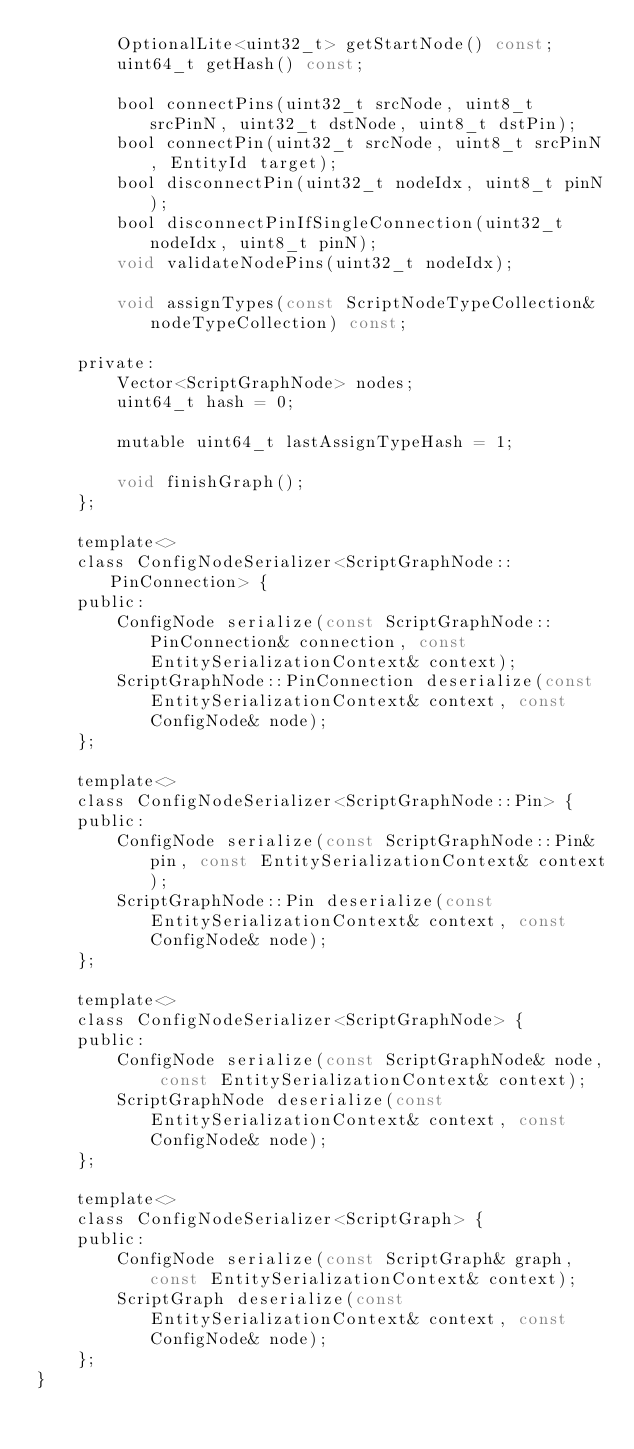Convert code to text. <code><loc_0><loc_0><loc_500><loc_500><_C_>		OptionalLite<uint32_t> getStartNode() const;
		uint64_t getHash() const;

		bool connectPins(uint32_t srcNode, uint8_t srcPinN, uint32_t dstNode, uint8_t dstPin);
		bool connectPin(uint32_t srcNode, uint8_t srcPinN, EntityId target);
		bool disconnectPin(uint32_t nodeIdx, uint8_t pinN);
		bool disconnectPinIfSingleConnection(uint32_t nodeIdx, uint8_t pinN);
		void validateNodePins(uint32_t nodeIdx);

		void assignTypes(const ScriptNodeTypeCollection& nodeTypeCollection) const;

	private:
		Vector<ScriptGraphNode> nodes;
		uint64_t hash = 0;

		mutable uint64_t lastAssignTypeHash = 1;

		void finishGraph();
	};

	template<>
	class ConfigNodeSerializer<ScriptGraphNode::PinConnection> {
	public:
		ConfigNode serialize(const ScriptGraphNode::PinConnection& connection, const EntitySerializationContext& context);
		ScriptGraphNode::PinConnection deserialize(const EntitySerializationContext& context, const ConfigNode& node);
	};

	template<>
	class ConfigNodeSerializer<ScriptGraphNode::Pin> {
	public:
		ConfigNode serialize(const ScriptGraphNode::Pin& pin, const EntitySerializationContext& context);
		ScriptGraphNode::Pin deserialize(const EntitySerializationContext& context, const ConfigNode& node);
	};

	template<>
	class ConfigNodeSerializer<ScriptGraphNode> {
	public:
		ConfigNode serialize(const ScriptGraphNode& node, const EntitySerializationContext& context);
		ScriptGraphNode deserialize(const EntitySerializationContext& context, const ConfigNode& node);
	};

	template<>
	class ConfigNodeSerializer<ScriptGraph> {
	public:
		ConfigNode serialize(const ScriptGraph& graph, const EntitySerializationContext& context);
		ScriptGraph deserialize(const EntitySerializationContext& context, const ConfigNode& node);
	};
}
</code> 